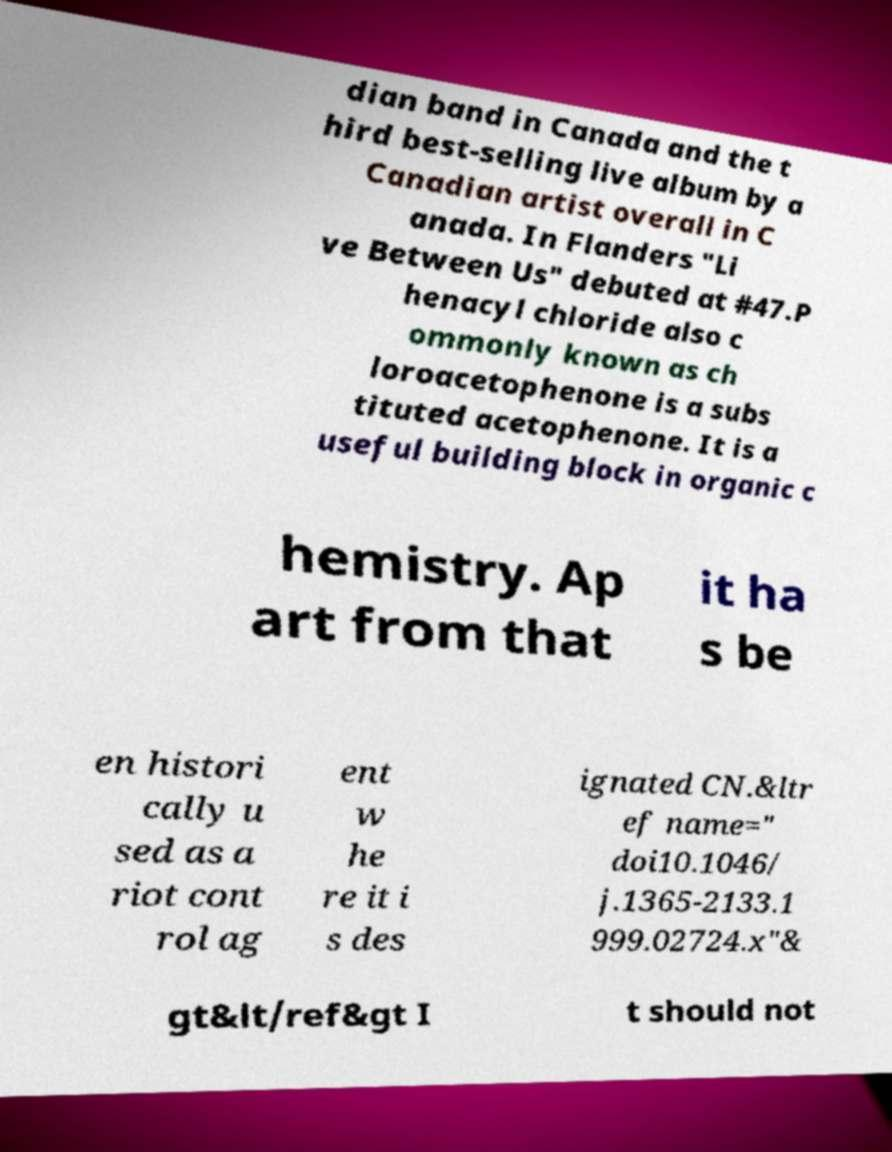Can you accurately transcribe the text from the provided image for me? dian band in Canada and the t hird best-selling live album by a Canadian artist overall in C anada. In Flanders "Li ve Between Us" debuted at #47.P henacyl chloride also c ommonly known as ch loroacetophenone is a subs tituted acetophenone. It is a useful building block in organic c hemistry. Ap art from that it ha s be en histori cally u sed as a riot cont rol ag ent w he re it i s des ignated CN.&ltr ef name=" doi10.1046/ j.1365-2133.1 999.02724.x"& gt&lt/ref&gt I t should not 